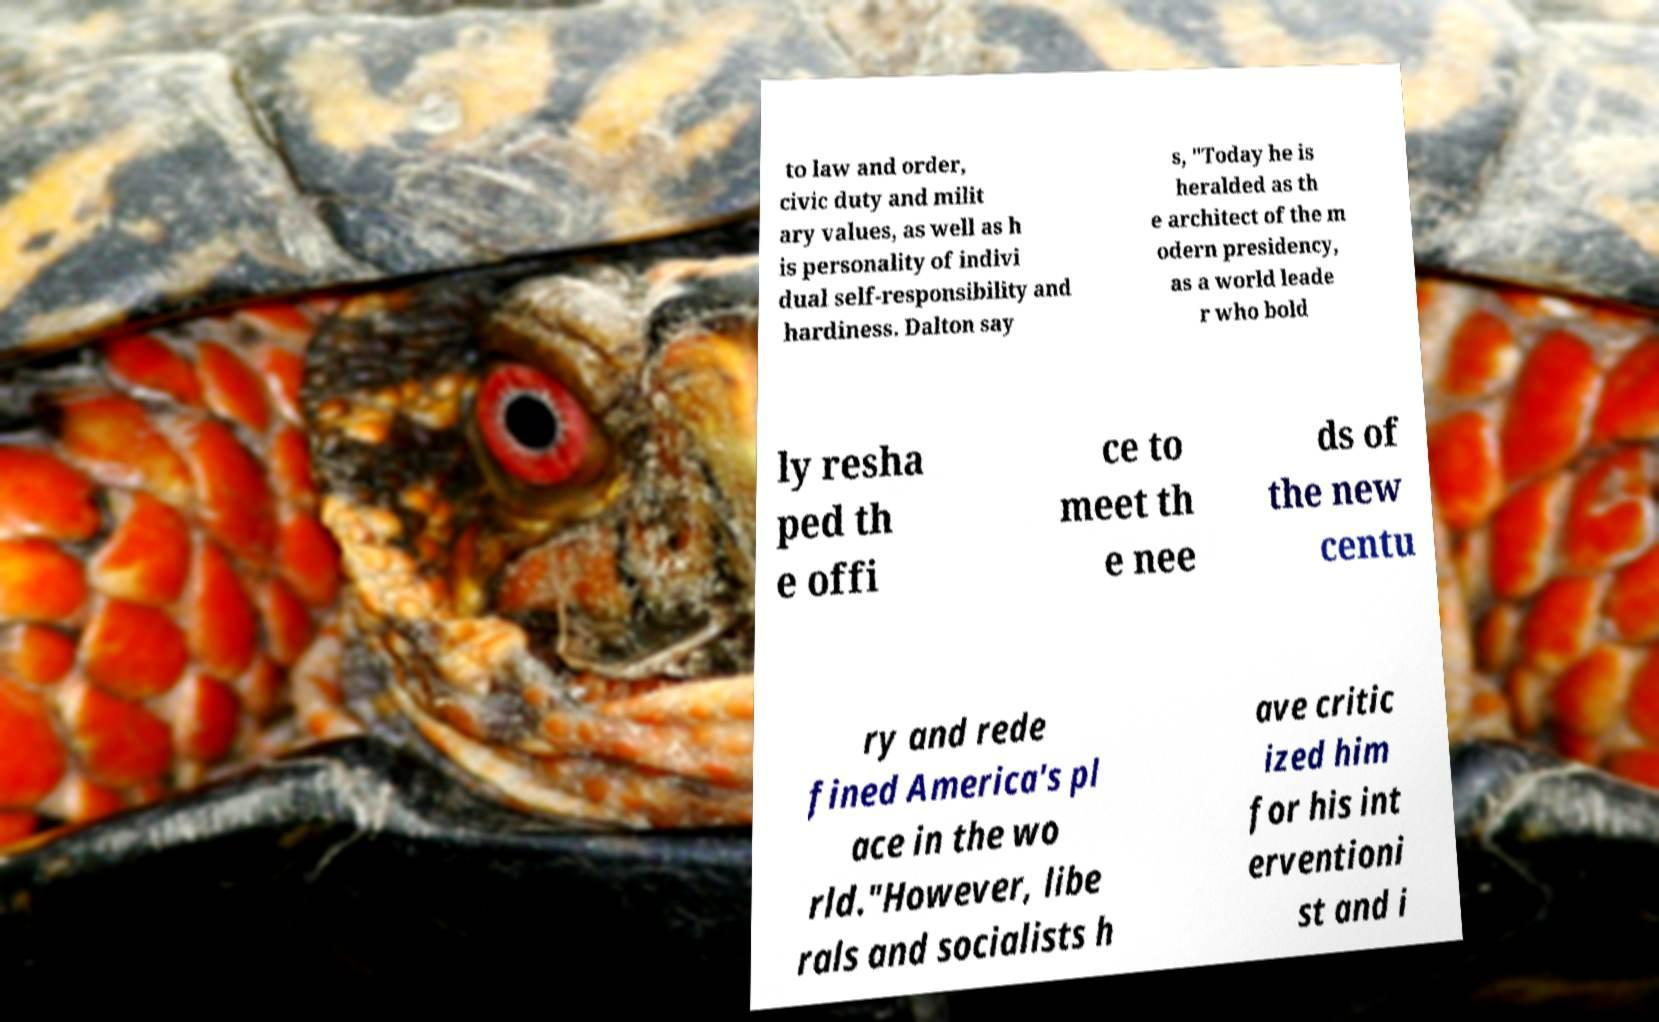There's text embedded in this image that I need extracted. Can you transcribe it verbatim? to law and order, civic duty and milit ary values, as well as h is personality of indivi dual self-responsibility and hardiness. Dalton say s, "Today he is heralded as th e architect of the m odern presidency, as a world leade r who bold ly resha ped th e offi ce to meet th e nee ds of the new centu ry and rede fined America's pl ace in the wo rld."However, libe rals and socialists h ave critic ized him for his int erventioni st and i 